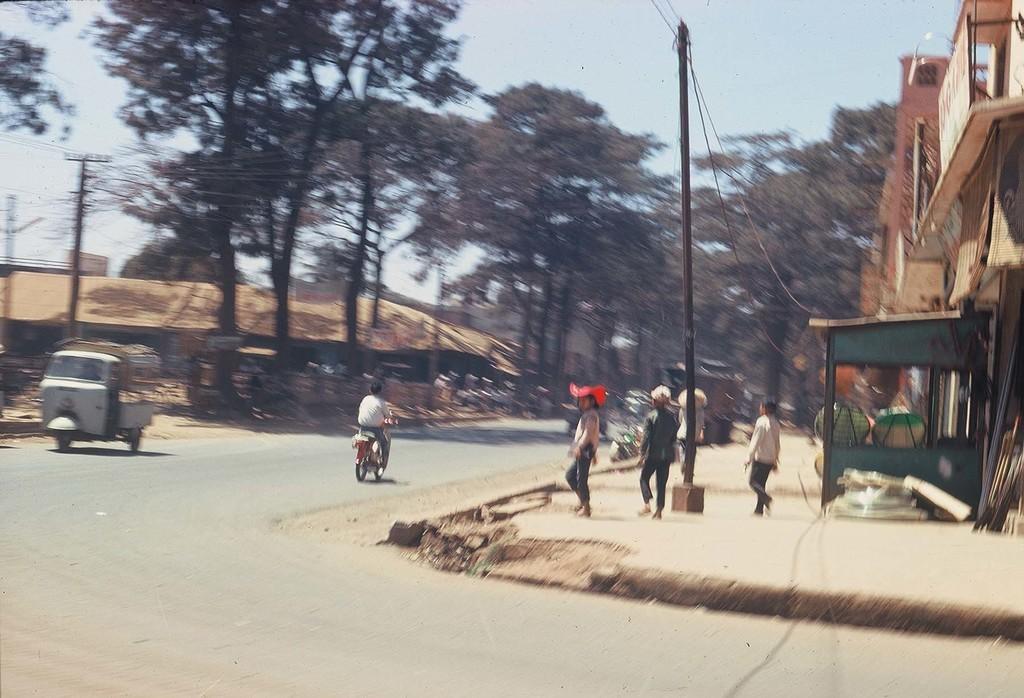Please provide a concise description of this image. In this image I can see a group of people, street lights, wires and vehicles on the road. In the background I can see buildings, trees and the sky. This image is taken may be during a day. 